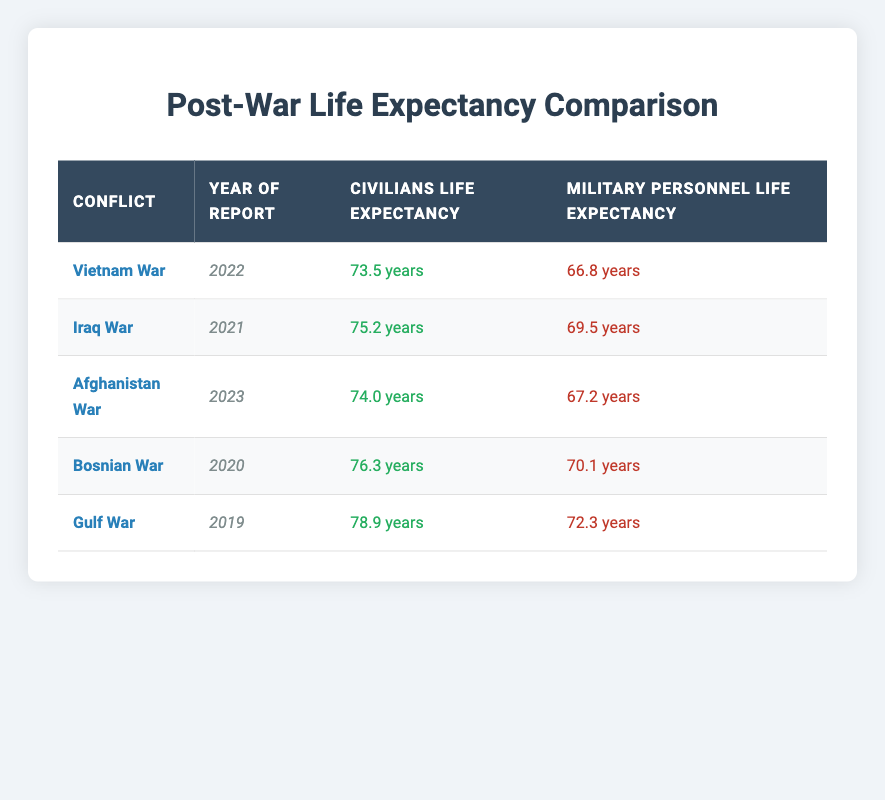What was the life expectancy of civilians during the Vietnam War? According to the table, the life expectancy of civilians during the Vietnam War in 2022 is listed as 73.5 years.
Answer: 73.5 years What conflict had the lowest life expectancy for military personnel? To find this, I compare the life expectancies of military personnel across all conflicts: 66.8 (Vietnam War), 69.5 (Iraq War), 67.2 (Afghanistan War), 70.1 (Bosnian War), and 72.3 (Gulf War). The lowest is 66.8 years from the Vietnam War.
Answer: Vietnam War Is the life expectancy of civilians always higher than that of military personnel? By checking the table, it shows that in all instances listed, civilians have a higher life expectancy compared to military personnel. Thus, the answer is yes.
Answer: Yes What is the average life expectancy of civilians across all listed conflicts? I add the life expectancies of civilians: 73.5 (Vietnam) + 75.2 (Iraq) + 74.0 (Afghanistan) + 76.3 (Bosnian) + 78.9 (Gulf) = 378.9. There are 5 data points, so I divide this total by 5, leading to an average of 378.9 / 5 = 75.78 years.
Answer: 75.78 years How much lower is the military personnel life expectancy compared to civilians in the Gulf War? For the Gulf War, civilians have a life expectancy of 78.9 years while military personnel have 72.3 years. The difference is 78.9 - 72.3 = 6.6 years, indicating that military personnel's life expectancy is 6.6 years lower.
Answer: 6.6 years Has the military personnel life expectancy increased or decreased from the Vietnam War to the Iraq War? In the Vietnam War, the military personnel life expectancy was 66.8 years, and in the Iraq War, it was 69.5 years. Since 69.5 is greater than 66.8, it indicates there was an increase over this period.
Answer: Increased Which conflict has the highest civilian life expectancy? Checking the life expectancy values for civilians: 73.5 (Vietnam), 75.2 (Iraq), 74.0 (Afghanistan), 76.3 (Bosnian), and 78.9 (Gulf). The highest is 78.9 years from the Gulf War.
Answer: Gulf War Was the life expectancy of military personnel during the Afghanistan War higher than during the Gulf War? The life expectancy for military personnel in the Afghanistan War is 67.2 years, while in the Gulf War, it is 72.3 years. Since 67.2 is less than 72.3, the life expectancy during the Afghanistan War was lower.
Answer: No 